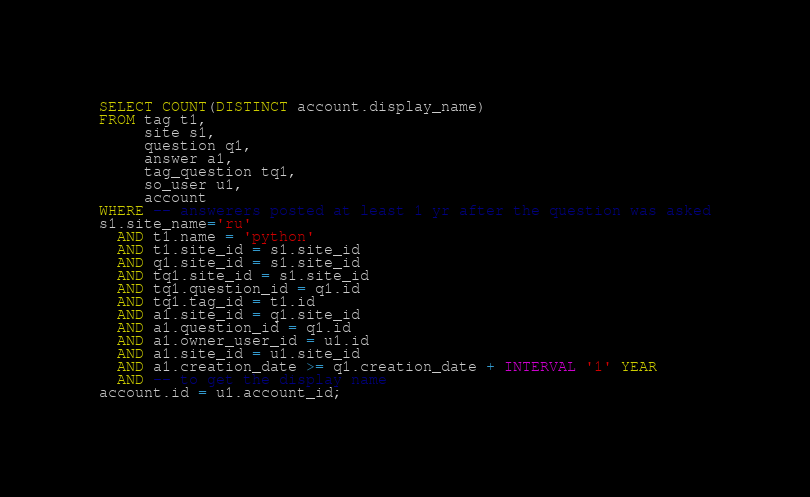<code> <loc_0><loc_0><loc_500><loc_500><_SQL_>
SELECT COUNT(DISTINCT account.display_name)
FROM tag t1,
     site s1,
     question q1,
     answer a1,
     tag_question tq1,
     so_user u1,
     account
WHERE -- answerers posted at least 1 yr after the question was asked
s1.site_name='ru'
  AND t1.name = 'python'
  AND t1.site_id = s1.site_id
  AND q1.site_id = s1.site_id
  AND tq1.site_id = s1.site_id
  AND tq1.question_id = q1.id
  AND tq1.tag_id = t1.id
  AND a1.site_id = q1.site_id
  AND a1.question_id = q1.id
  AND a1.owner_user_id = u1.id
  AND a1.site_id = u1.site_id
  AND a1.creation_date >= q1.creation_date + INTERVAL '1' YEAR
  AND -- to get the display name
account.id = u1.account_id;</code> 